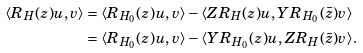Convert formula to latex. <formula><loc_0><loc_0><loc_500><loc_500>\langle R _ { H } ( z ) u , v \rangle & = \langle R _ { H _ { 0 } } ( z ) u , v \rangle - \langle Z R _ { H } ( z ) u , Y R _ { H _ { 0 } } ( \bar { z } ) v \rangle \\ & = \langle R _ { H _ { 0 } } ( z ) u , v \rangle - \langle Y R _ { H _ { 0 } } ( z ) u , Z R _ { H } ( \bar { z } ) v \rangle .</formula> 